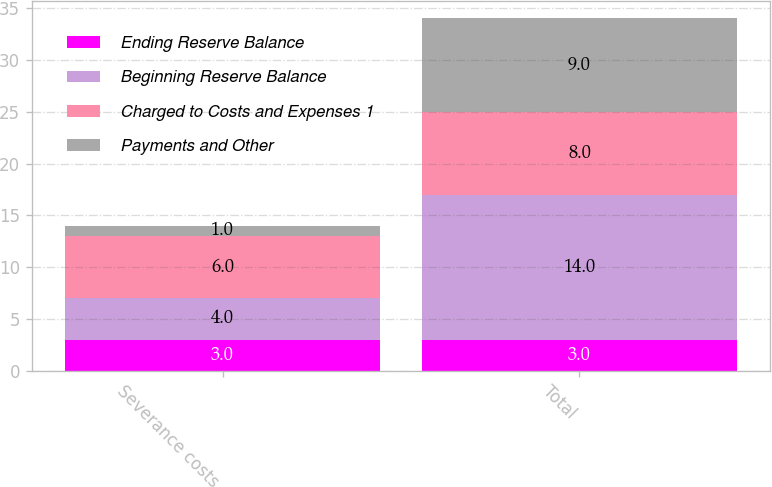Convert chart. <chart><loc_0><loc_0><loc_500><loc_500><stacked_bar_chart><ecel><fcel>Severance costs<fcel>Total<nl><fcel>Ending Reserve Balance<fcel>3<fcel>3<nl><fcel>Beginning Reserve Balance<fcel>4<fcel>14<nl><fcel>Charged to Costs and Expenses 1<fcel>6<fcel>8<nl><fcel>Payments and Other<fcel>1<fcel>9<nl></chart> 